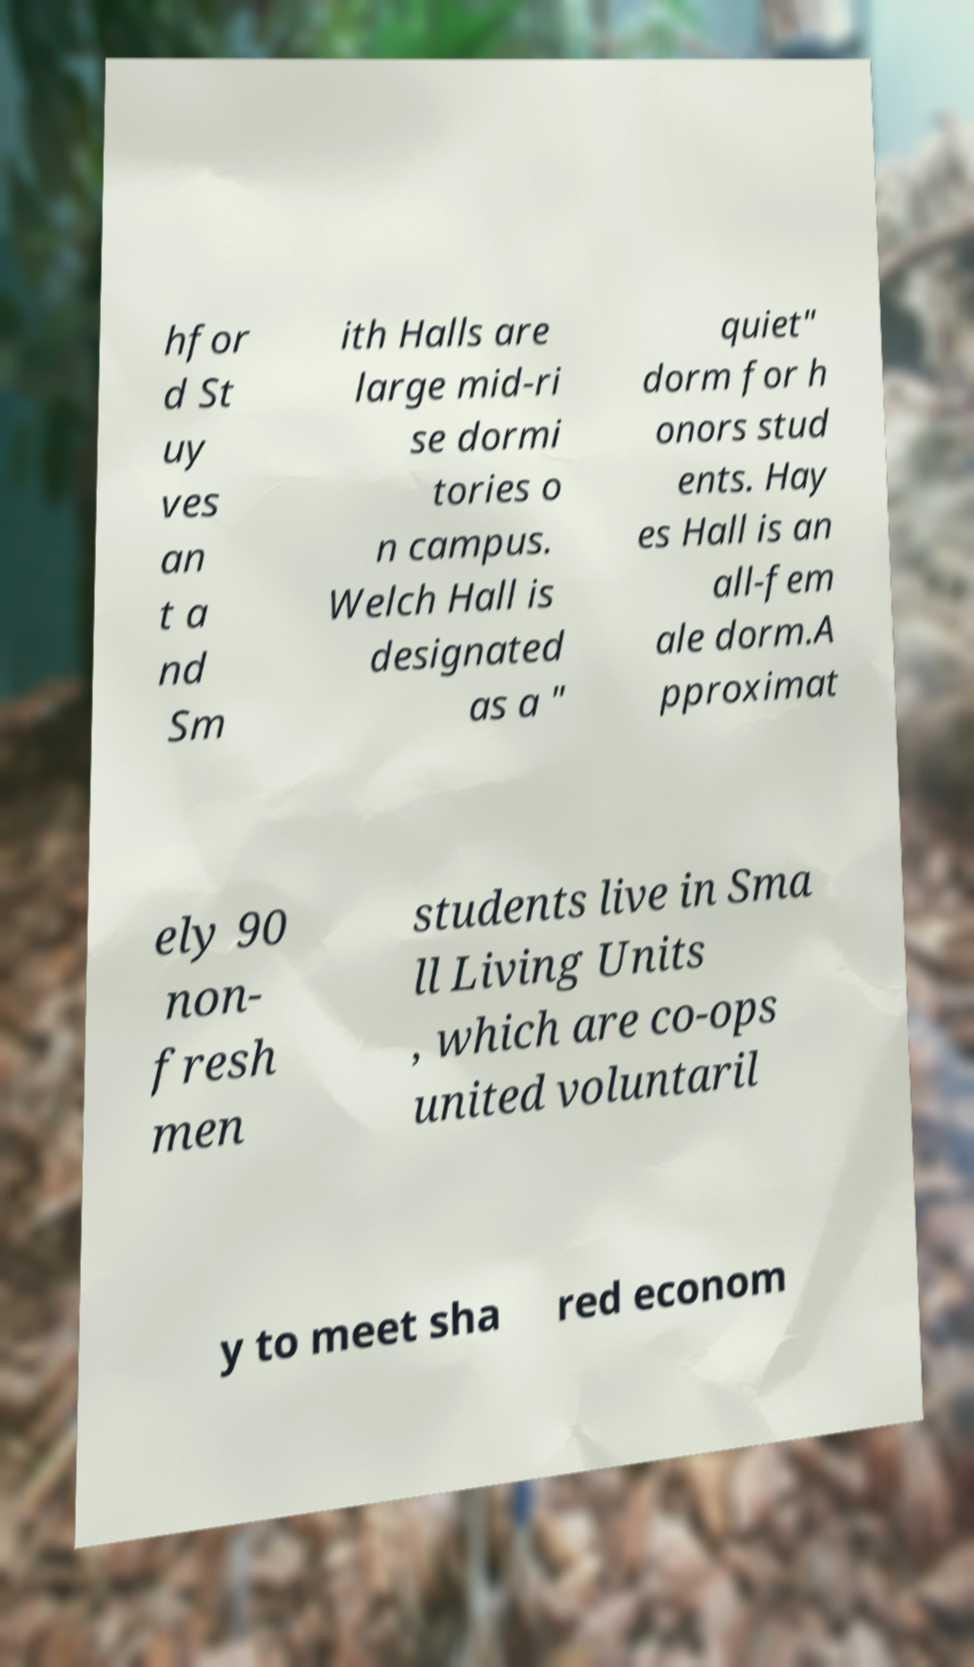Please identify and transcribe the text found in this image. hfor d St uy ves an t a nd Sm ith Halls are large mid-ri se dormi tories o n campus. Welch Hall is designated as a " quiet" dorm for h onors stud ents. Hay es Hall is an all-fem ale dorm.A pproximat ely 90 non- fresh men students live in Sma ll Living Units , which are co-ops united voluntaril y to meet sha red econom 